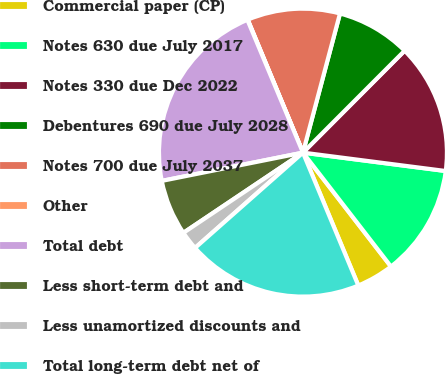Convert chart to OTSL. <chart><loc_0><loc_0><loc_500><loc_500><pie_chart><fcel>Commercial paper (CP)<fcel>Notes 630 due July 2017<fcel>Notes 330 due Dec 2022<fcel>Debentures 690 due July 2028<fcel>Notes 700 due July 2037<fcel>Other<fcel>Total debt<fcel>Less short-term debt and<fcel>Less unamortized discounts and<fcel>Total long-term debt net of<nl><fcel>4.19%<fcel>12.49%<fcel>14.56%<fcel>8.34%<fcel>10.41%<fcel>0.04%<fcel>21.84%<fcel>6.26%<fcel>2.11%<fcel>19.77%<nl></chart> 